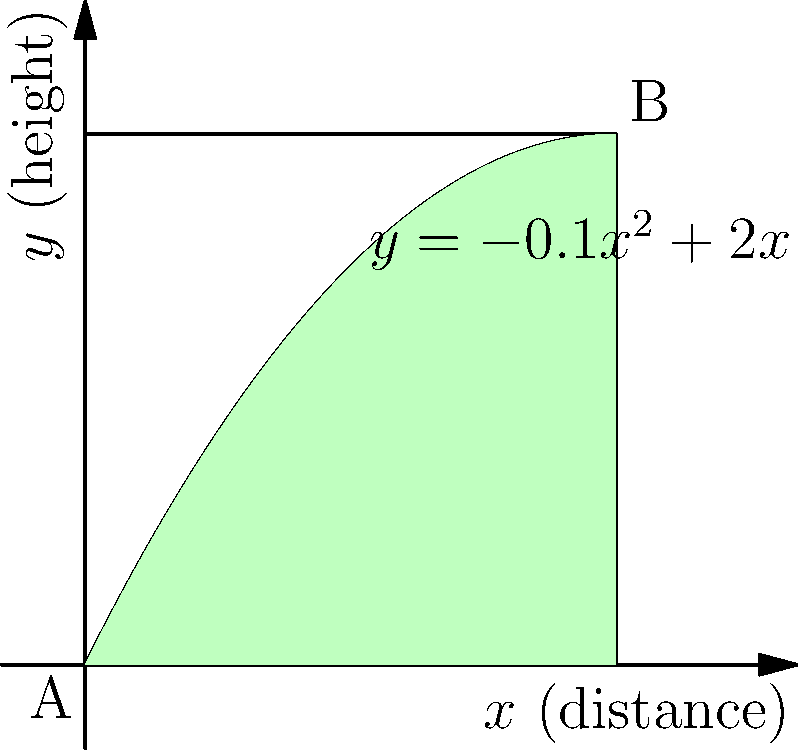As a golf instructor, you're analyzing the flight path of a golf ball. The path is modeled by the function $y = -0.1x^2 + 2x$, where $x$ represents the horizontal distance (in meters) and $y$ represents the height (in meters). Calculate the area between the curve and the x-axis from point A (0,0) to point B (10,10), which represents the total distance traveled by the ball. To find the area under the curve, we need to integrate the function from x = 0 to x = 10.

1) The function is $y = -0.1x^2 + 2x$

2) Set up the integral:
   $$\int_0^{10} (-0.1x^2 + 2x) dx$$

3) Integrate:
   $$[-0.1 \cdot \frac{x^3}{3} + x^2]_0^{10}$$

4) Evaluate the integral:
   $$(-0.1 \cdot \frac{1000}{3} + 100) - (-0.1 \cdot 0 + 0)$$
   $$= (-33.33 + 100) - 0$$
   $$= 66.67$$

5) Therefore, the area under the curve is approximately 66.67 square meters.
Answer: 66.67 square meters 